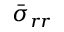<formula> <loc_0><loc_0><loc_500><loc_500>\bar { \sigma } _ { r r }</formula> 